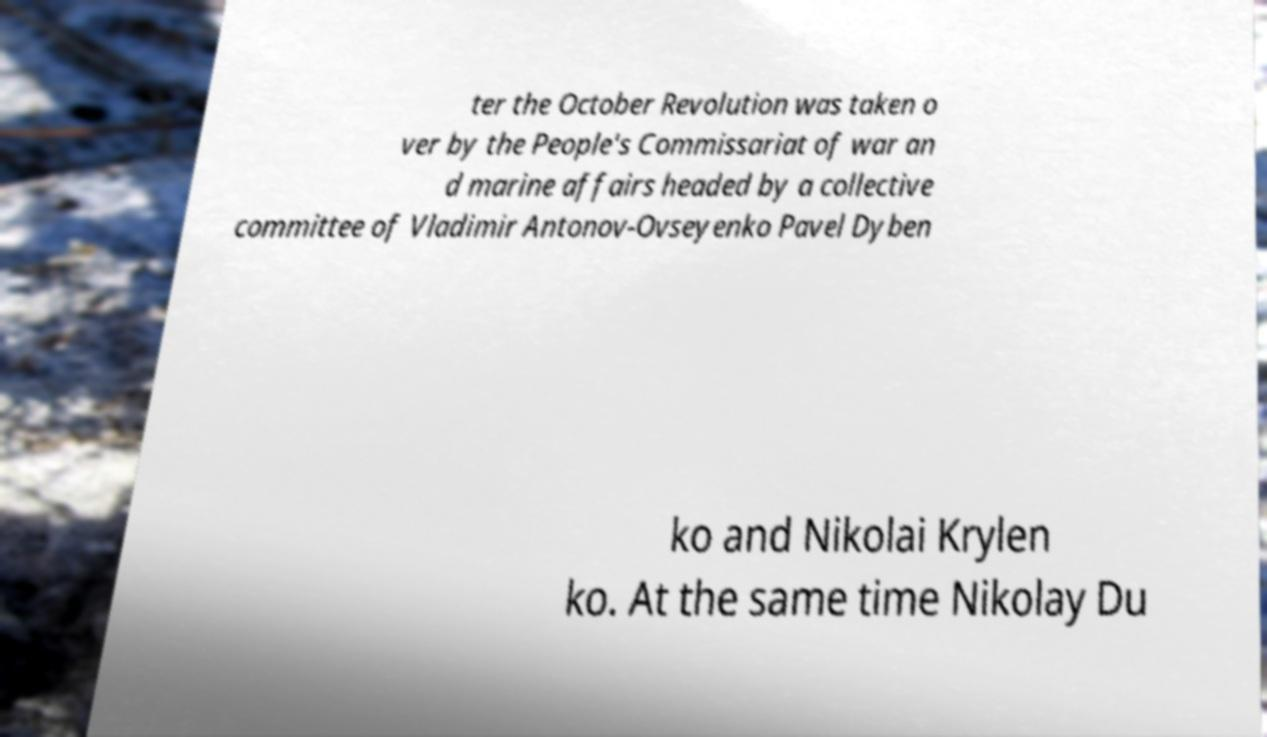Please read and relay the text visible in this image. What does it say? ter the October Revolution was taken o ver by the People's Commissariat of war an d marine affairs headed by a collective committee of Vladimir Antonov-Ovseyenko Pavel Dyben ko and Nikolai Krylen ko. At the same time Nikolay Du 